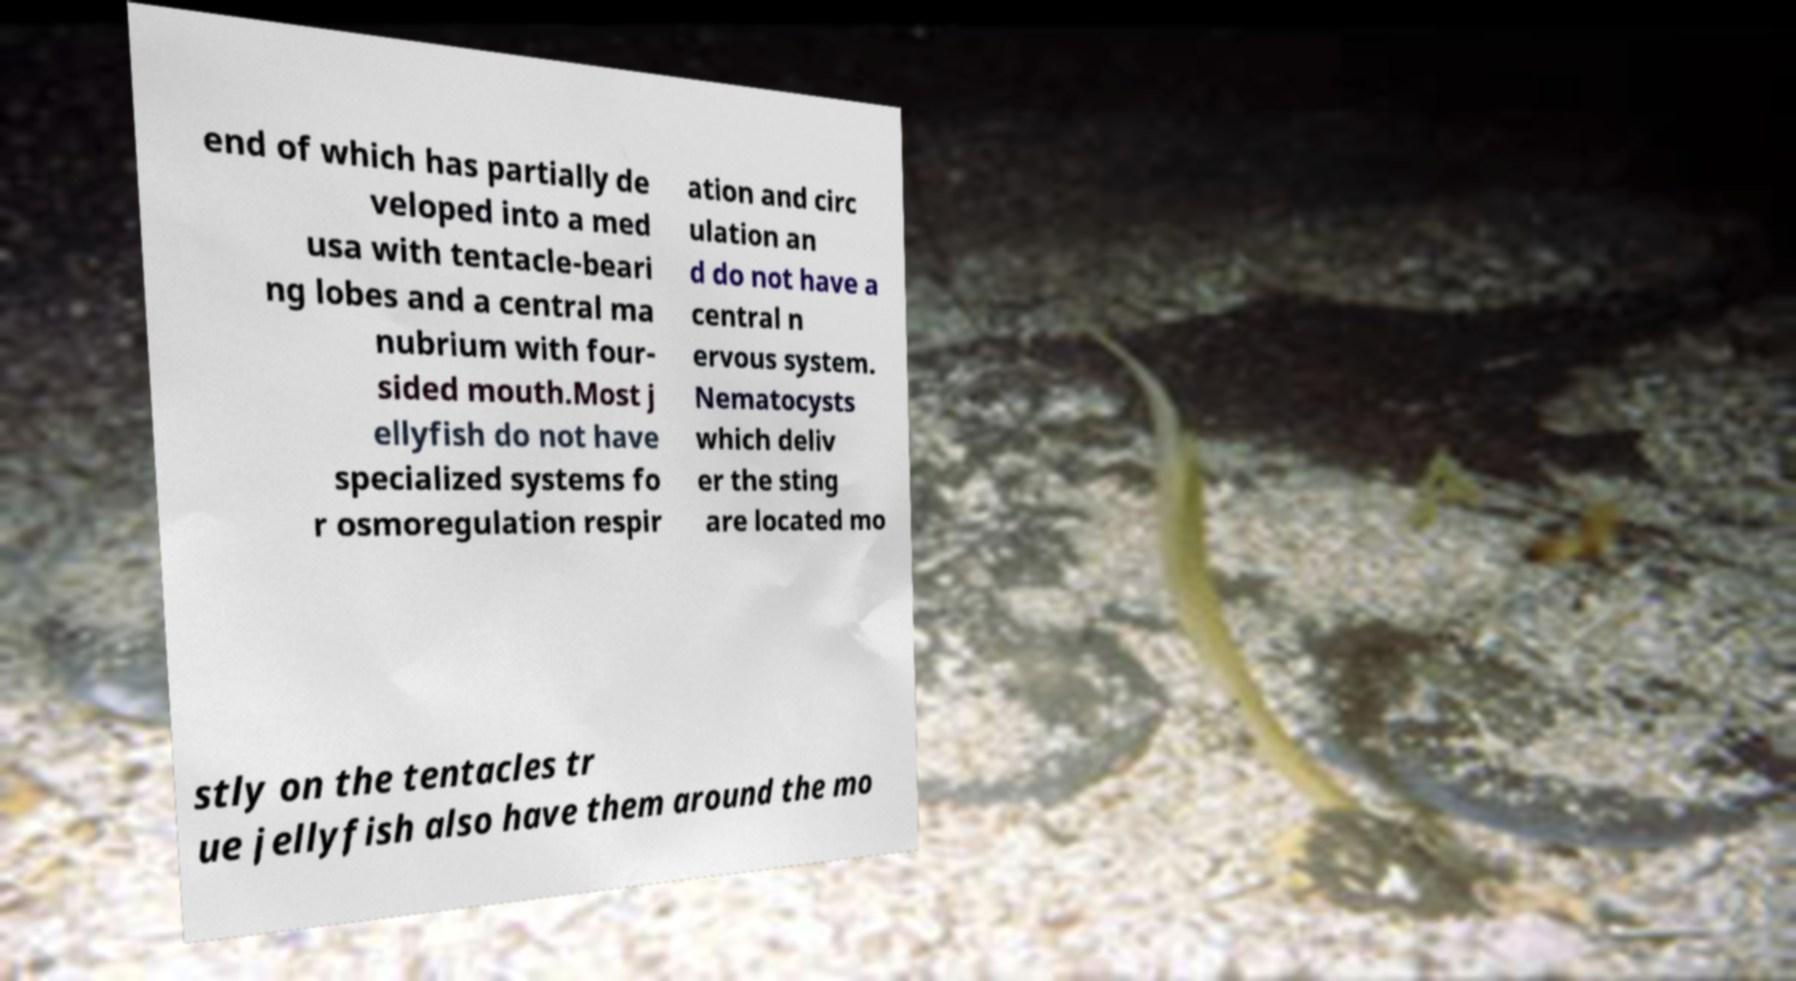Please identify and transcribe the text found in this image. end of which has partially de veloped into a med usa with tentacle-beari ng lobes and a central ma nubrium with four- sided mouth.Most j ellyfish do not have specialized systems fo r osmoregulation respir ation and circ ulation an d do not have a central n ervous system. Nematocysts which deliv er the sting are located mo stly on the tentacles tr ue jellyfish also have them around the mo 